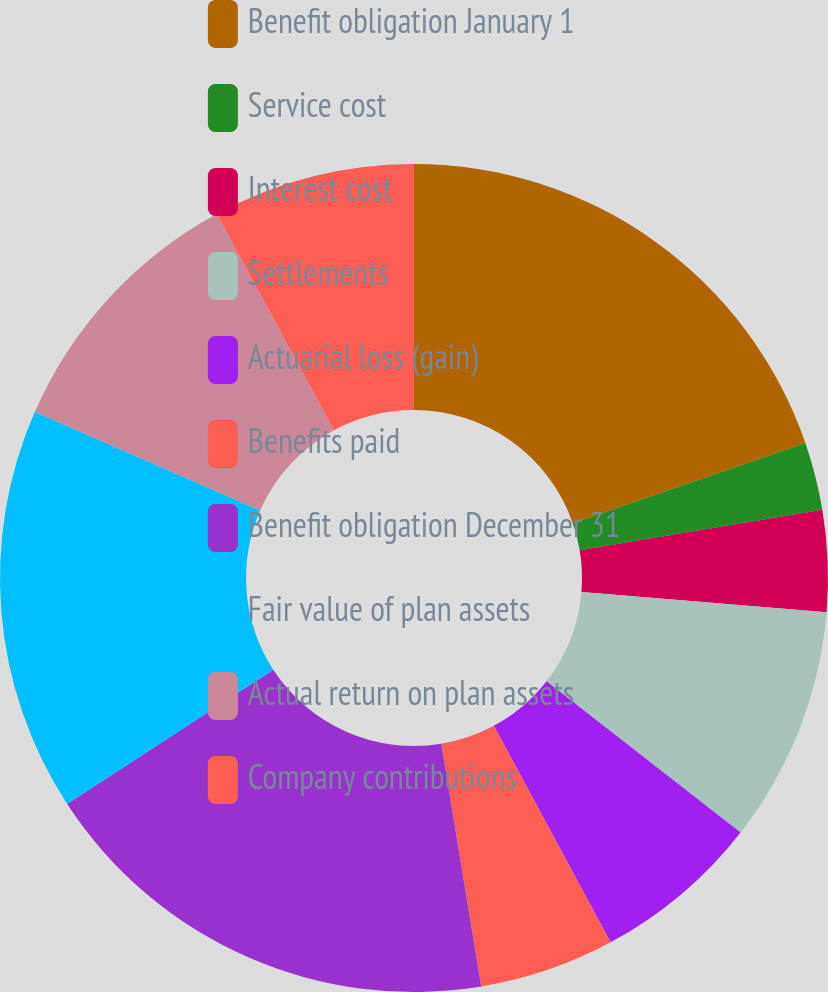Convert chart to OTSL. <chart><loc_0><loc_0><loc_500><loc_500><pie_chart><fcel>Benefit obligation January 1<fcel>Service cost<fcel>Interest cost<fcel>Settlements<fcel>Actuarial loss (gain)<fcel>Benefits paid<fcel>Benefit obligation December 31<fcel>Fair value of plan assets<fcel>Actual return on plan assets<fcel>Company contributions<nl><fcel>19.71%<fcel>2.65%<fcel>3.96%<fcel>9.21%<fcel>6.59%<fcel>5.28%<fcel>18.4%<fcel>15.77%<fcel>10.52%<fcel>7.9%<nl></chart> 